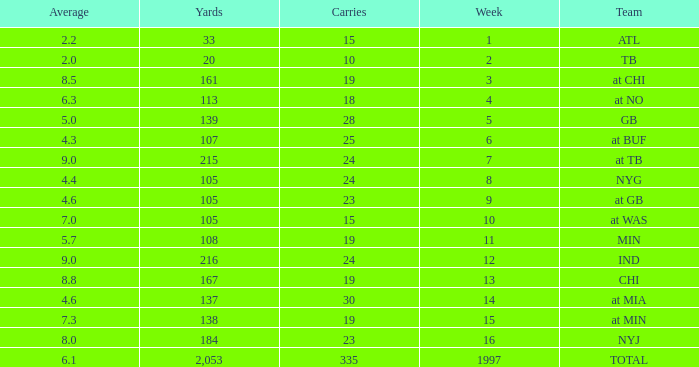5? None. 